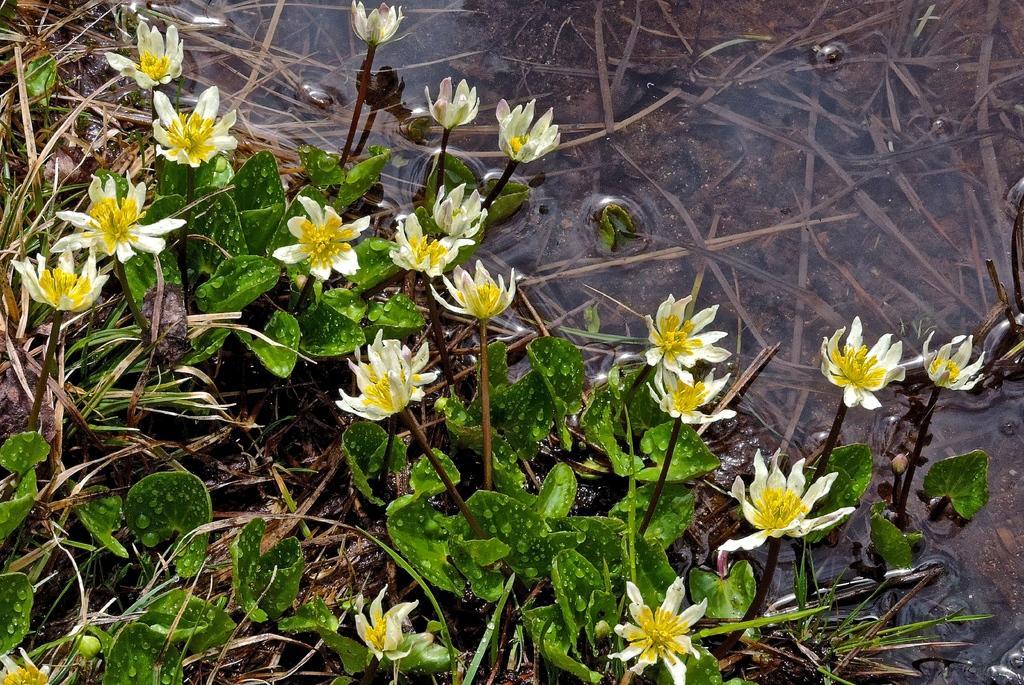Describe this image in one or two sentences. In the foreground of this image, there are flowers to the plants and on the top, there is water and grass under it. 